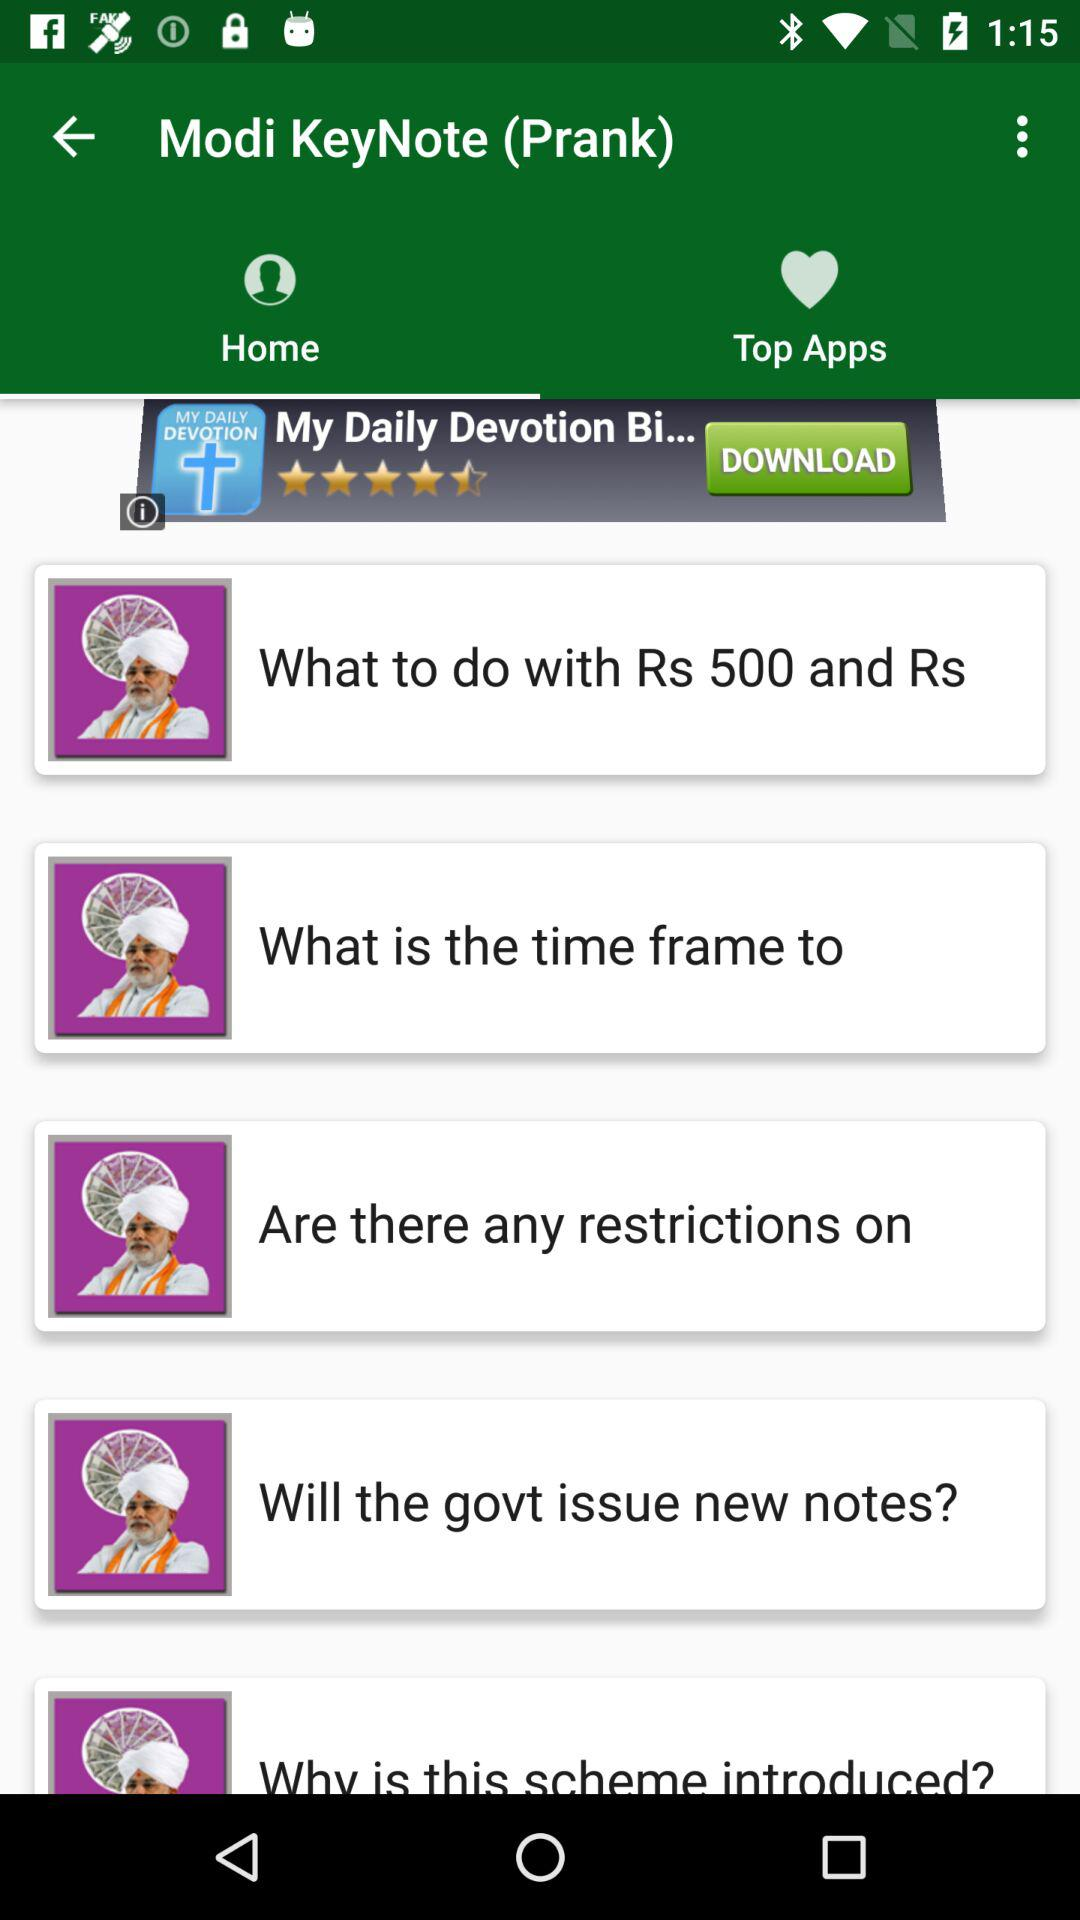What is the application name in the advertisement? The application name in the advertisement is "My Daily Devotion Bi...". 